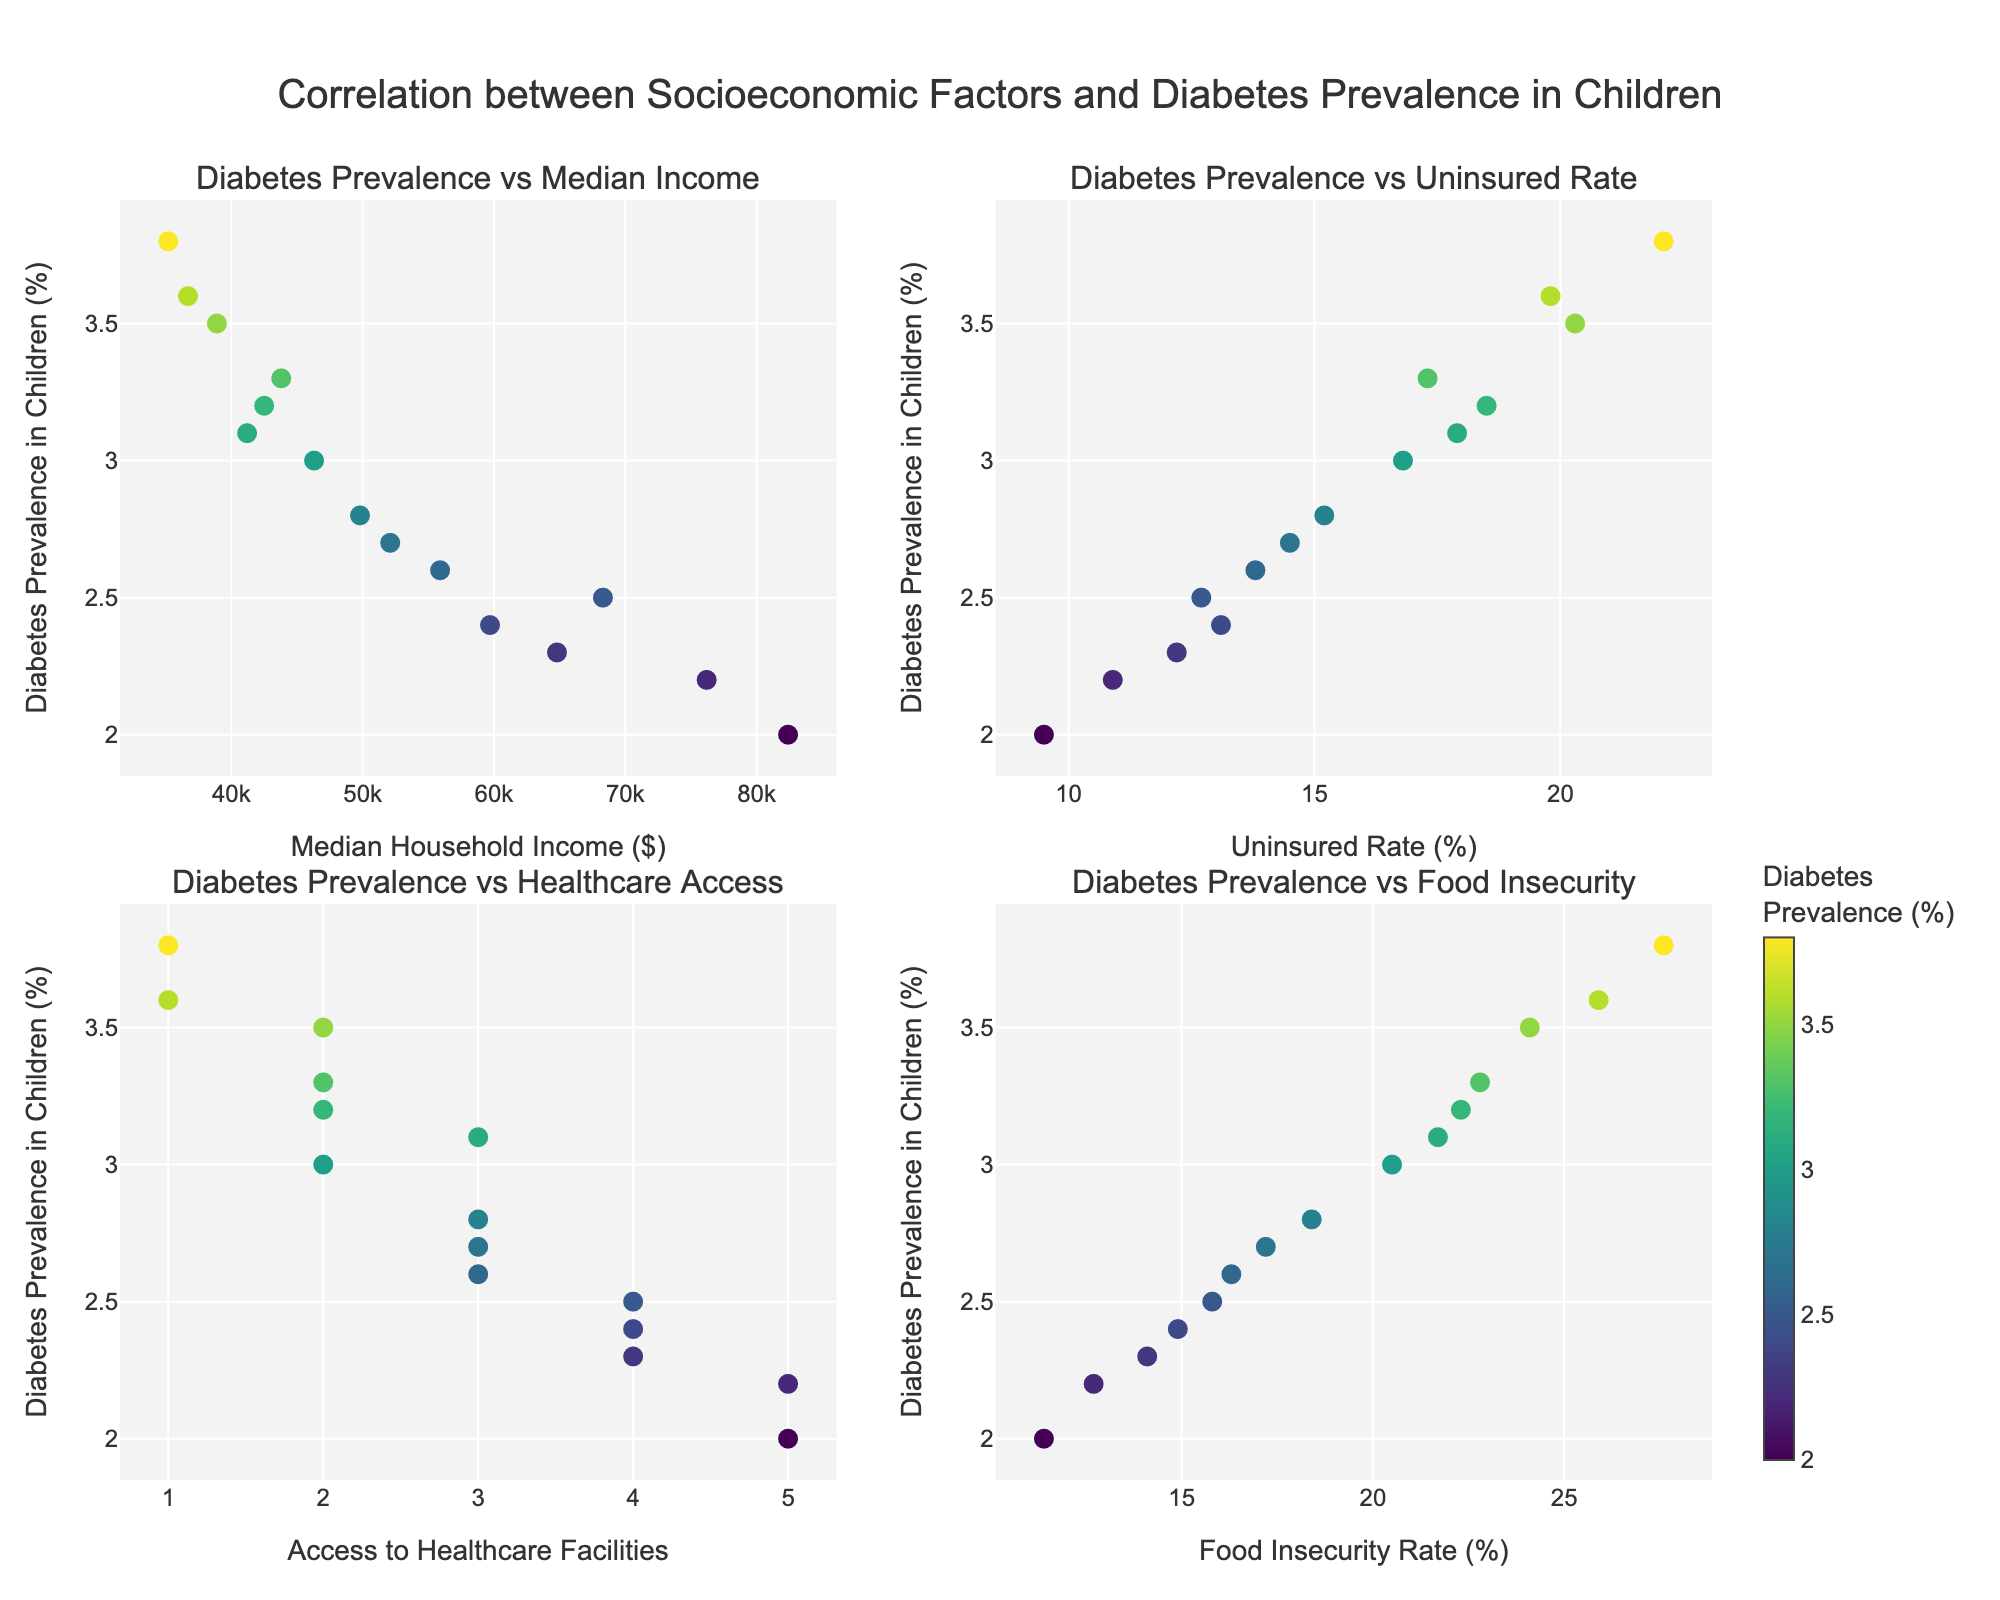How many census tracts are depicted in the figure? By counting the number of unique points (or census tracts) on any of the four subplots, we can determine the number of census tracts depicted in the figure.
Answer: 15 Which subplot shows the relationship between diabetes prevalence and median household income? The subplot titles are labeled at the top of each subplot. The title of the top-left subplot is "Diabetes Prevalence vs Median Income."
Answer: The top-left subplot What is the general trend between median household income and diabetes prevalence in children? By observing the top-left subplot, we can see if the trend slope is positive (increasing) or negative (decreasing). The trend appears to show that as median household income increases, diabetes prevalence in children tends to decrease.
Answer: Negative correlation Which census tract has the highest diabetes prevalence and what are its median household income and uninsured rate? To find the census tract with the highest diabetes prevalence, look for the highest point on the y-axis of all subplots. The (vertical) hover-over information provides this data. The highest point corresponds to census tract 90011, with a 3.8% diabetes prevalence, and a median household income of $35,200, and an uninsured rate of 22.1%.
Answer: Census tract 90011, Median Household Income: $35,200, Uninsured Rate: 22.1% Compare the access to healthcare facilities for census tracts with the highest and lowest diabetes prevalence rates. The census tract with the lowest diabetes prevalence (top-right point) likely belongs to the one with a prevalence of 2.0% in the bottom-right subplot. By comparing the healthcare access facilities of these tracts, we can determine the difference. Census tract 90033 (highest) has an access rating of 1, while census tract 90505 (lowest) has an access rating of 5.
Answer: Highest (90011): 1, Lowest (90505): 5 What is the relationship between the food insecurity rate and diabetes prevalence in children? By reviewing the bottom-right subplot and observing the trend slope, we can determine if the correlation is positive or negative. There appears to be a general trend where higher food insecurity rates correlate with higher diabetes prevalence in children.
Answer: Positive correlation Identify which subplot shows the strongest correlation with diabetes prevalence in children. By visually comparing the spread and clustering of the points in each subplot, and also considering the hover information, we can infer which relationship is the most linear or most correlated. The subplot showing "Diabetes Prevalence vs Median Income" (top-left) appears to have a more defined and stronger negative correlation compared to other subplots.
Answer: Top-left subplot What is the diabetes prevalence in census tracts with at least 4 healthcare facilities? By checking the bottom-left subplot and looking for points where the x-axis (healthcare facilities) equals 4, then referring to their y-axis (diabetes prevalence) values respectively, these tracts have prevalence rates of 2.4%, 2.2%, and 2.3%.
Answer: 2.4%, 2.2%, 2.3% How does the uninsured rate vary in census tracts with the highest food insecurity rate? By reviewing the bottom-right subplot and identifying the point with the highest x-axis value (food insecurity rate), then cross-checking it with the top-right subplot (uninsured rate), the highest food insecurity rate of 27.6% in tract 90011 correlates with an uninsured rate of 22.1%.
Answer: 22.1% 